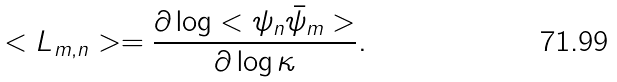<formula> <loc_0><loc_0><loc_500><loc_500>< L _ { m , n } > = \frac { \partial \log < \psi _ { n } \bar { \psi } _ { m } > } { \partial \log \kappa } .</formula> 